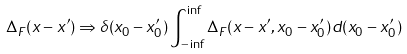<formula> <loc_0><loc_0><loc_500><loc_500>\Delta _ { F } ( x - x ^ { \prime } ) \Rightarrow \delta ( x _ { 0 } - x _ { 0 } ^ { \prime } ) \int _ { - \inf } ^ { \inf } \Delta _ { F } ( { x - x ^ { \prime } } , x _ { 0 } - x _ { 0 } ^ { \prime } ) d ( x _ { 0 } - x _ { 0 } ^ { \prime } )</formula> 